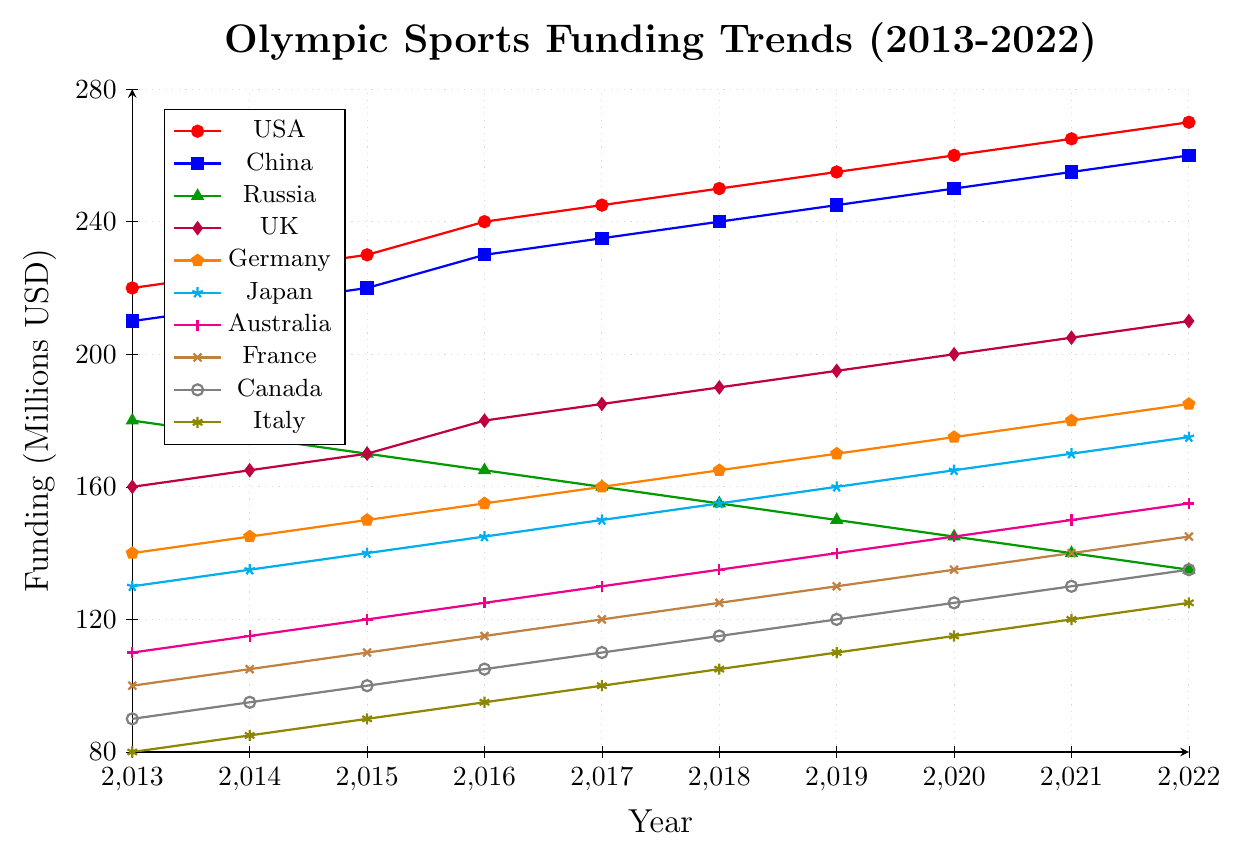Which country had the highest funding in 2022? To find this, look at the end of the plot for 2022 and compare the funding levels of all the countries. USA has the highest value at 270 million USD.
Answer: USA How did the funding for Russia change from 2013 to 2022? Compare the funding allocation for Russia at the start of the plot (2013) and the end (2022). In 2013, Russia's funding was 180 million USD, and in 2022, it was 135 million USD, showing a decrease of 45 million USD.
Answer: Decreased by 45 million USD What is the trend in funding for the UK over the decade? Observe the funding points for the UK from 2013 to 2022. The trend shows a steady increase from 160 million USD in 2013 to 210 million USD in 2022.
Answer: Steadily increasing Which countries had a constant increase in funding every year? Look for countries whose funding values consistently increased over each consecutive year from 2013 to 2022. USA, China, UK, Germany, Japan, and Australia all show a consistent yearly increase.
Answer: USA, China, UK, Germany, Japan, Australia Compare the funding changes between China and the USA from 2013 to 2022. Calculate the difference in funding for each country between 2013 and 2022. China increased from 210 to 260 million USD, a change of 50 million USD. USA increased from 220 to 270 million USD, a change of 50 million USD. Both countries had an equal increase of 50 million USD.
Answer: Equal, both increased by 50 million USD Which country had the lowest funding in 2017, and what was the amount? Examine the 2017 data points and identify the country with the lowest value. Italy had the lowest funding at 100 million USD.
Answer: Italy, 100 million USD What is the average funding for Germany over the decade? Sum the funding amounts for Germany from 2013 to 2022 and divide by the number of years (10). The sum of funding for Germany is 1515 million USD, so the average is 151.5 million USD.
Answer: 151.5 million USD Between which years did Canada experience the highest increase in funding? Compare year-by-year funding changes for Canada. The highest increase occurred from 2016 to 2017, where the funding rose from 105 to 110 million USD, an increase of 5 million USD.
Answer: 2016-2017 Which countries saw a decrease in funding over the decade? Identify countries whose funding amounts decreased from 2013 to 2022. Russia and Italy both had a decrease in funding, with Russia decreasing by 45 million USD and Italy by 45 million USD.
Answer: Russia, Italy What is the total funding for Japan from 2013 to 2022? Sum the funding amounts for Japan over the 10 years. The total funding is the sum of (130+135+140+145+150+155+160+165+170+175) = 1525 million USD.
Answer: 1525 million USD 